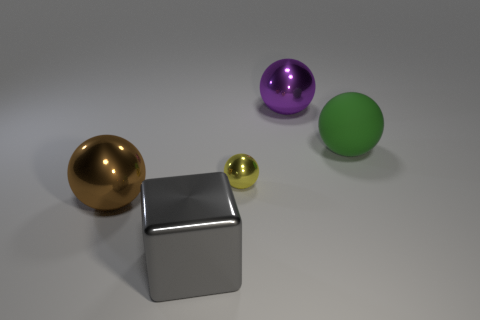Subtract 1 spheres. How many spheres are left? 3 Add 5 big purple balls. How many objects exist? 10 Subtract all blocks. How many objects are left? 4 Subtract all large purple shiny balls. Subtract all large spheres. How many objects are left? 1 Add 3 brown objects. How many brown objects are left? 4 Add 3 tiny things. How many tiny things exist? 4 Subtract 1 yellow balls. How many objects are left? 4 